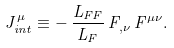Convert formula to latex. <formula><loc_0><loc_0><loc_500><loc_500>J _ { i n t } ^ { \mu } \equiv - \, \frac { L _ { F F } } { L _ { F } } \, F _ { , \nu } \, F ^ { \mu \nu } .</formula> 